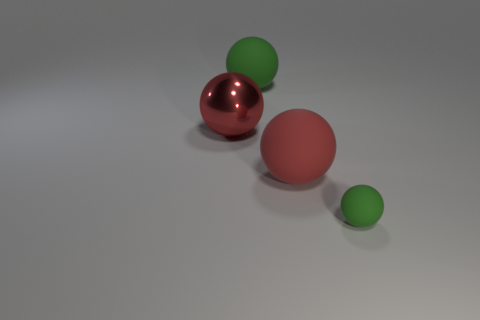There is a big green matte thing; does it have the same shape as the big matte object in front of the large metal thing?
Provide a succinct answer. Yes. There is a large red thing that is behind the large red thing that is on the right side of the green thing behind the tiny matte ball; what is its material?
Keep it short and to the point. Metal. What number of red objects are there?
Offer a very short reply. 2. What number of gray things are large matte things or small matte spheres?
Keep it short and to the point. 0. What number of other objects are there of the same shape as the large red rubber thing?
Offer a very short reply. 3. Is the color of the large rubber thing in front of the big green rubber ball the same as the thing that is to the left of the big green rubber thing?
Give a very brief answer. Yes. What number of tiny objects are either yellow metal cubes or red rubber objects?
Offer a terse response. 0. There is a red rubber thing that is the same shape as the large shiny thing; what is its size?
Offer a very short reply. Large. Is there anything else that is the same size as the metal sphere?
Your answer should be very brief. Yes. What is the big red object on the right side of the green sphere that is behind the small rubber thing made of?
Your answer should be very brief. Rubber. 